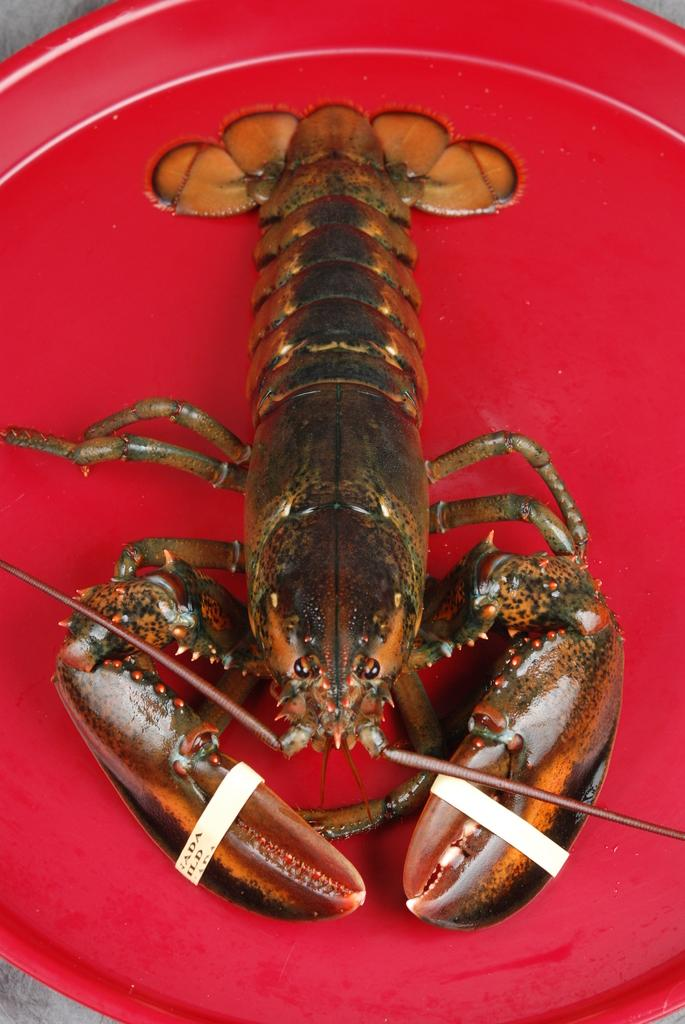What type of seafood is on the plate in the image? There is a lobster on a plate in the image. What type of grain is visible in the image? There is no grain visible in the image; it only features a lobster on a plate. Can you describe the room where the lobster is located in the image? The provided fact does not mention a room or any surrounding environment, so it cannot be described. 